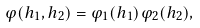Convert formula to latex. <formula><loc_0><loc_0><loc_500><loc_500>\varphi ( h _ { 1 } , h _ { 2 } ) = \varphi _ { 1 } ( h _ { 1 } ) \varphi _ { 2 } ( h _ { 2 } ) ,</formula> 